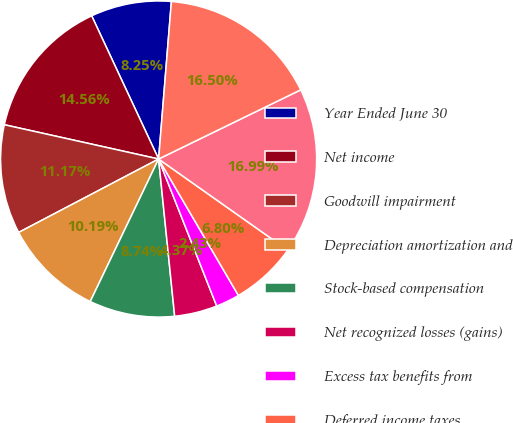Convert chart to OTSL. <chart><loc_0><loc_0><loc_500><loc_500><pie_chart><fcel>Year Ended June 30<fcel>Net income<fcel>Goodwill impairment<fcel>Depreciation amortization and<fcel>Stock-based compensation<fcel>Net recognized losses (gains)<fcel>Excess tax benefits from<fcel>Deferred income taxes<fcel>Deferral of unearned revenue<fcel>Recognition of unearned<nl><fcel>8.25%<fcel>14.56%<fcel>11.17%<fcel>10.19%<fcel>8.74%<fcel>4.37%<fcel>2.43%<fcel>6.8%<fcel>16.99%<fcel>16.5%<nl></chart> 